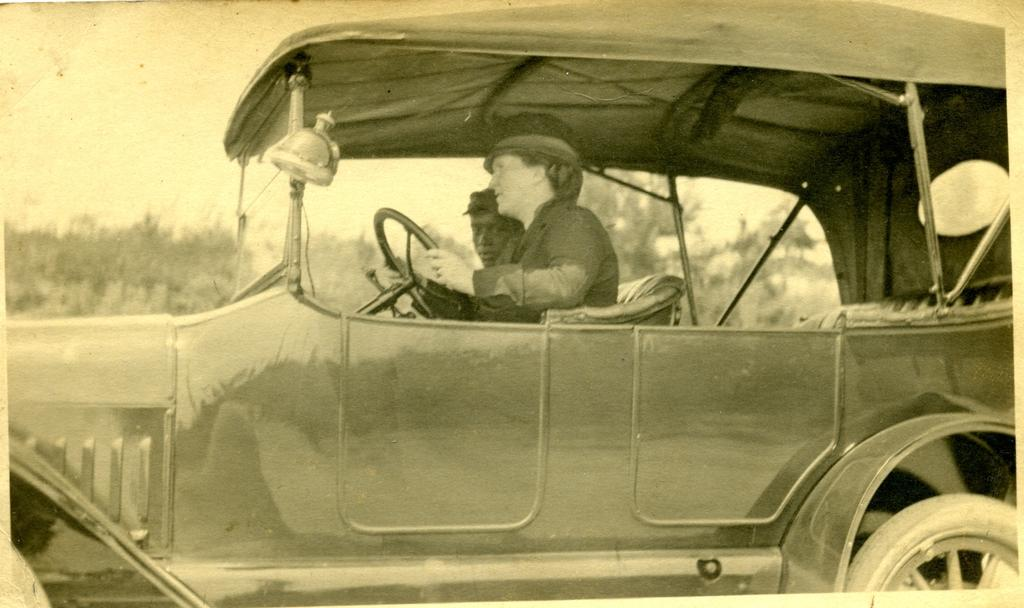What is the color scheme of the image? The image is black and white. What can be seen inside the car in the image? There are two persons sitting inside the car. What type of car is featured in the image? The car is vintage. What can be seen in the background of the image? There are trees visible in the background. How many bricks are visible on the car in the image? There are no bricks visible on the car in the image. What type of bomb can be seen in the background? There is no bomb present in the image; it features a vintage car with two persons inside and trees in the background. 